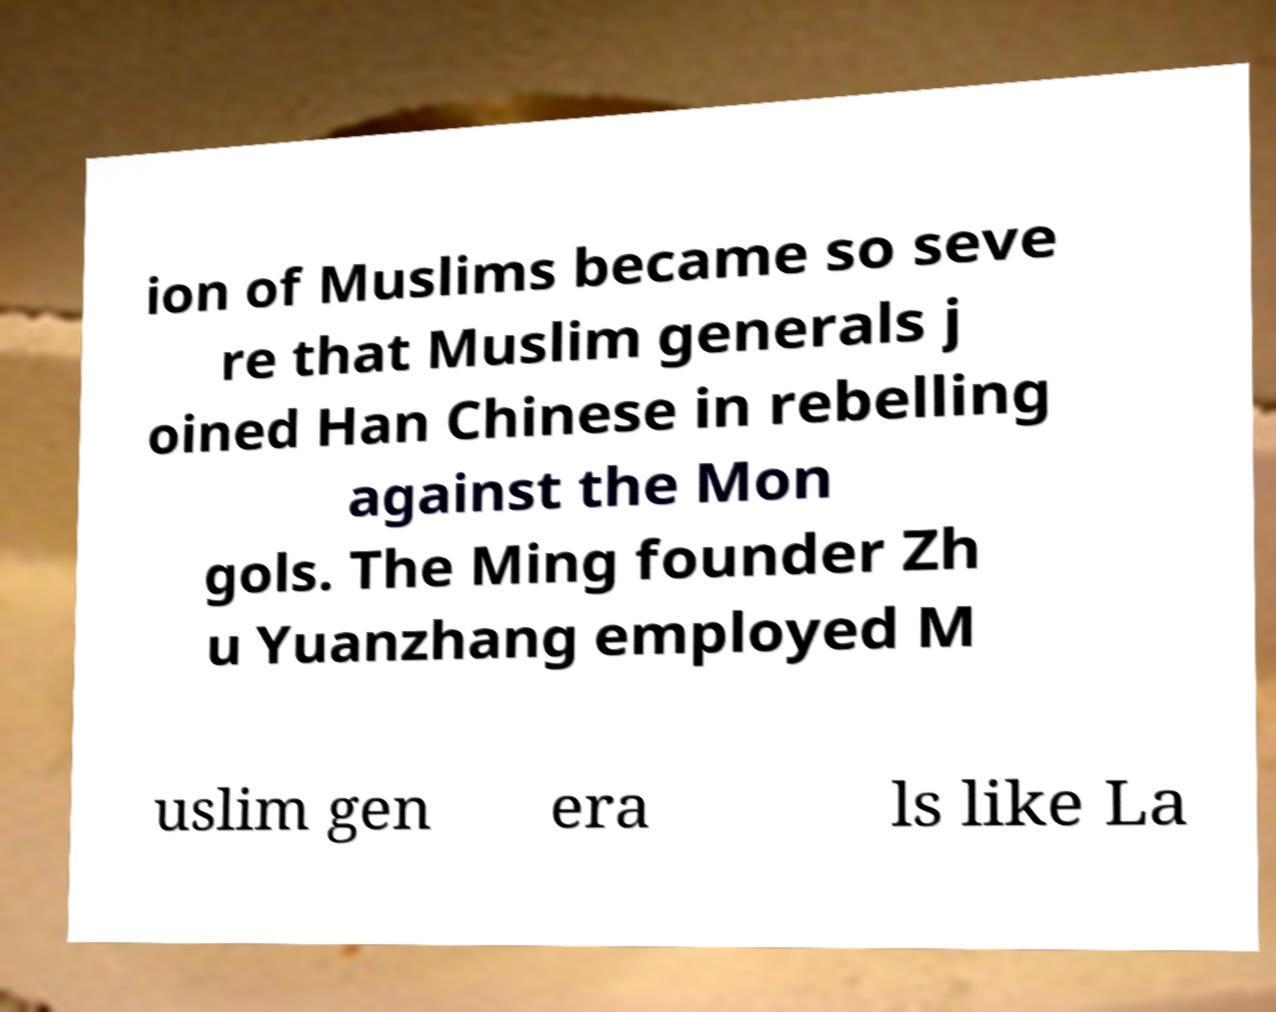Please identify and transcribe the text found in this image. ion of Muslims became so seve re that Muslim generals j oined Han Chinese in rebelling against the Mon gols. The Ming founder Zh u Yuanzhang employed M uslim gen era ls like La 